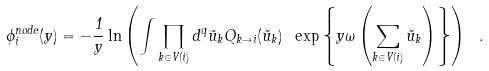Convert formula to latex. <formula><loc_0><loc_0><loc_500><loc_500>\phi _ { i } ^ { n o d e } ( y ) = - \frac { 1 } { y } \ln \left ( \int \prod _ { k \in V ( i ) } d ^ { q } \vec { u } _ { k } Q _ { k \to i } ( \vec { u } _ { k } ) \ \exp \left \{ y \omega \left ( \sum _ { k \in V ( i ) } \vec { u } _ { k } \right ) \right \} \right ) \ .</formula> 